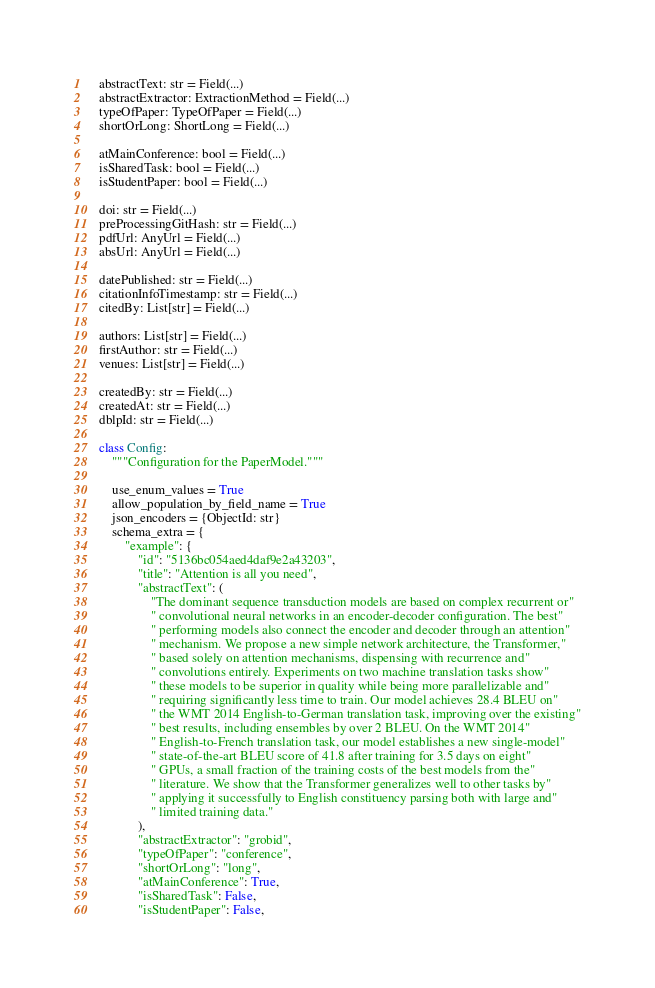<code> <loc_0><loc_0><loc_500><loc_500><_Python_>    abstractText: str = Field(...)
    abstractExtractor: ExtractionMethod = Field(...)
    typeOfPaper: TypeOfPaper = Field(...)
    shortOrLong: ShortLong = Field(...)

    atMainConference: bool = Field(...)
    isSharedTask: bool = Field(...)
    isStudentPaper: bool = Field(...)

    doi: str = Field(...)
    preProcessingGitHash: str = Field(...)
    pdfUrl: AnyUrl = Field(...)
    absUrl: AnyUrl = Field(...)

    datePublished: str = Field(...)
    citationInfoTimestamp: str = Field(...)
    citedBy: List[str] = Field(...)

    authors: List[str] = Field(...)
    firstAuthor: str = Field(...)
    venues: List[str] = Field(...)

    createdBy: str = Field(...)
    createdAt: str = Field(...)
    dblpId: str = Field(...)

    class Config:
        """Configuration for the PaperModel."""

        use_enum_values = True
        allow_population_by_field_name = True
        json_encoders = {ObjectId: str}
        schema_extra = {
            "example": {
                "id": "5136bc054aed4daf9e2a43203",
                "title": "Attention is all you need",
                "abstractText": (
                    "The dominant sequence transduction models are based on complex recurrent or"
                    " convolutional neural networks in an encoder-decoder configuration. The best"
                    " performing models also connect the encoder and decoder through an attention"
                    " mechanism. We propose a new simple network architecture, the Transformer,"
                    " based solely on attention mechanisms, dispensing with recurrence and"
                    " convolutions entirely. Experiments on two machine translation tasks show"
                    " these models to be superior in quality while being more parallelizable and"
                    " requiring significantly less time to train. Our model achieves 28.4 BLEU on"
                    " the WMT 2014 English-to-German translation task, improving over the existing"
                    " best results, including ensembles by over 2 BLEU. On the WMT 2014"
                    " English-to-French translation task, our model establishes a new single-model"
                    " state-of-the-art BLEU score of 41.8 after training for 3.5 days on eight"
                    " GPUs, a small fraction of the training costs of the best models from the"
                    " literature. We show that the Transformer generalizes well to other tasks by"
                    " applying it successfully to English constituency parsing both with large and"
                    " limited training data."
                ),
                "abstractExtractor": "grobid",
                "typeOfPaper": "conference",
                "shortOrLong": "long",
                "atMainConference": True,
                "isSharedTask": False,
                "isStudentPaper": False,</code> 